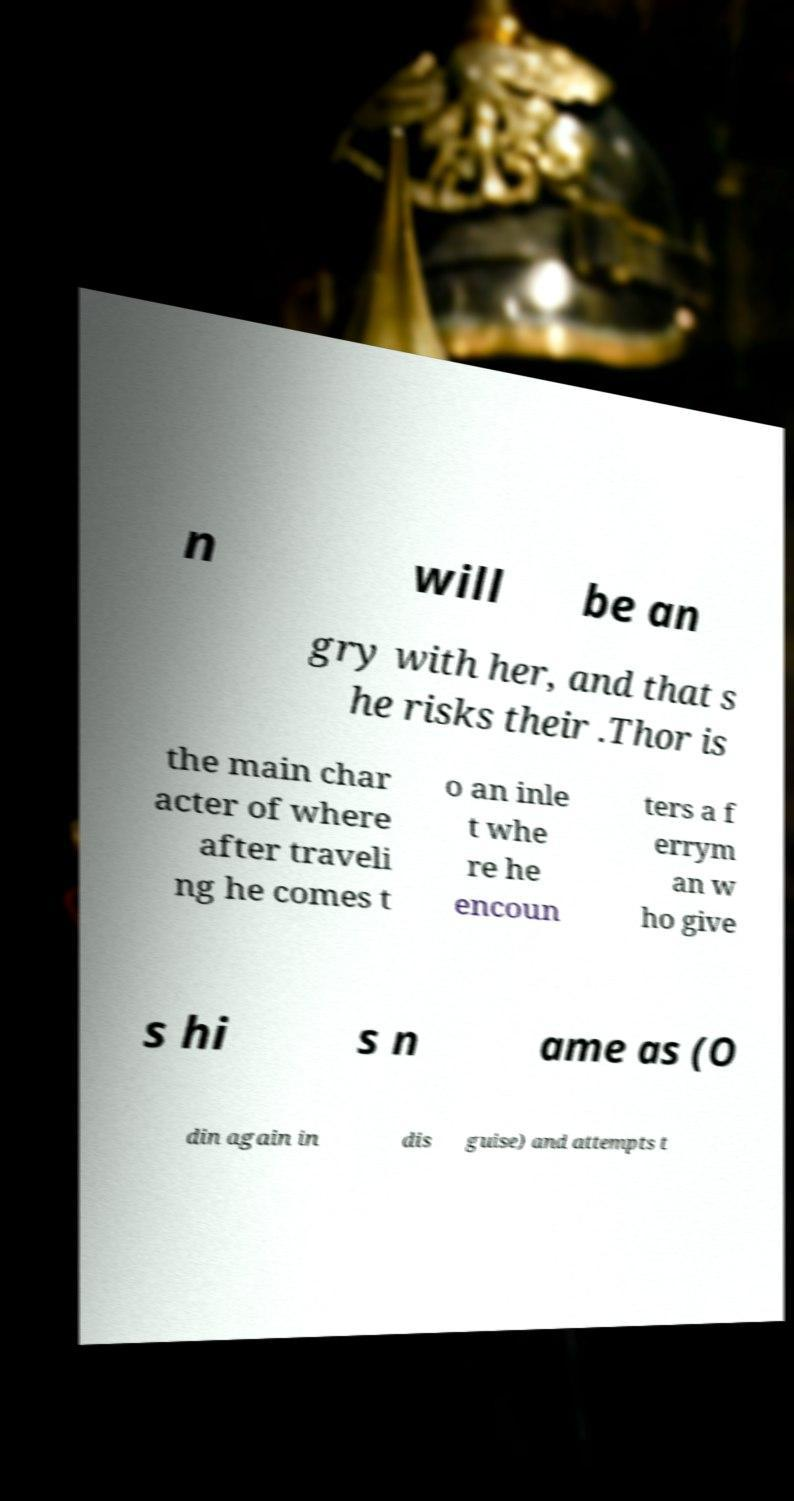Could you assist in decoding the text presented in this image and type it out clearly? n will be an gry with her, and that s he risks their .Thor is the main char acter of where after traveli ng he comes t o an inle t whe re he encoun ters a f errym an w ho give s hi s n ame as (O din again in dis guise) and attempts t 